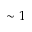Convert formula to latex. <formula><loc_0><loc_0><loc_500><loc_500>\sim 1</formula> 